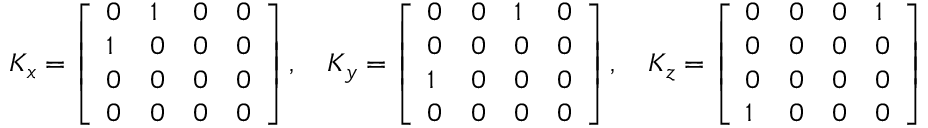Convert formula to latex. <formula><loc_0><loc_0><loc_500><loc_500>K _ { x } = { \left [ \begin{array} { l l l l } { 0 } & { 1 } & { 0 } & { 0 } \\ { 1 } & { 0 } & { 0 } & { 0 } \\ { 0 } & { 0 } & { 0 } & { 0 } \\ { 0 } & { 0 } & { 0 } & { 0 } \end{array} \right ] } \, , \quad K _ { y } = { \left [ \begin{array} { l l l l } { 0 } & { 0 } & { 1 } & { 0 } \\ { 0 } & { 0 } & { 0 } & { 0 } \\ { 1 } & { 0 } & { 0 } & { 0 } \\ { 0 } & { 0 } & { 0 } & { 0 } \end{array} \right ] } \, , \quad K _ { z } = { \left [ \begin{array} { l l l l } { 0 } & { 0 } & { 0 } & { 1 } \\ { 0 } & { 0 } & { 0 } & { 0 } \\ { 0 } & { 0 } & { 0 } & { 0 } \\ { 1 } & { 0 } & { 0 } & { 0 } \end{array} \right ] }</formula> 